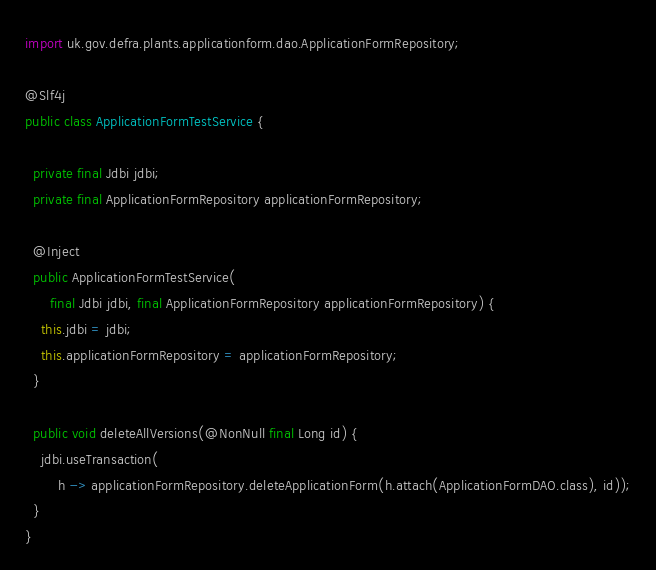<code> <loc_0><loc_0><loc_500><loc_500><_Java_>import uk.gov.defra.plants.applicationform.dao.ApplicationFormRepository;

@Slf4j
public class ApplicationFormTestService {

  private final Jdbi jdbi;
  private final ApplicationFormRepository applicationFormRepository;

  @Inject
  public ApplicationFormTestService(
      final Jdbi jdbi, final ApplicationFormRepository applicationFormRepository) {
    this.jdbi = jdbi;
    this.applicationFormRepository = applicationFormRepository;
  }

  public void deleteAllVersions(@NonNull final Long id) {
    jdbi.useTransaction(
        h -> applicationFormRepository.deleteApplicationForm(h.attach(ApplicationFormDAO.class), id));
  }
}
</code> 